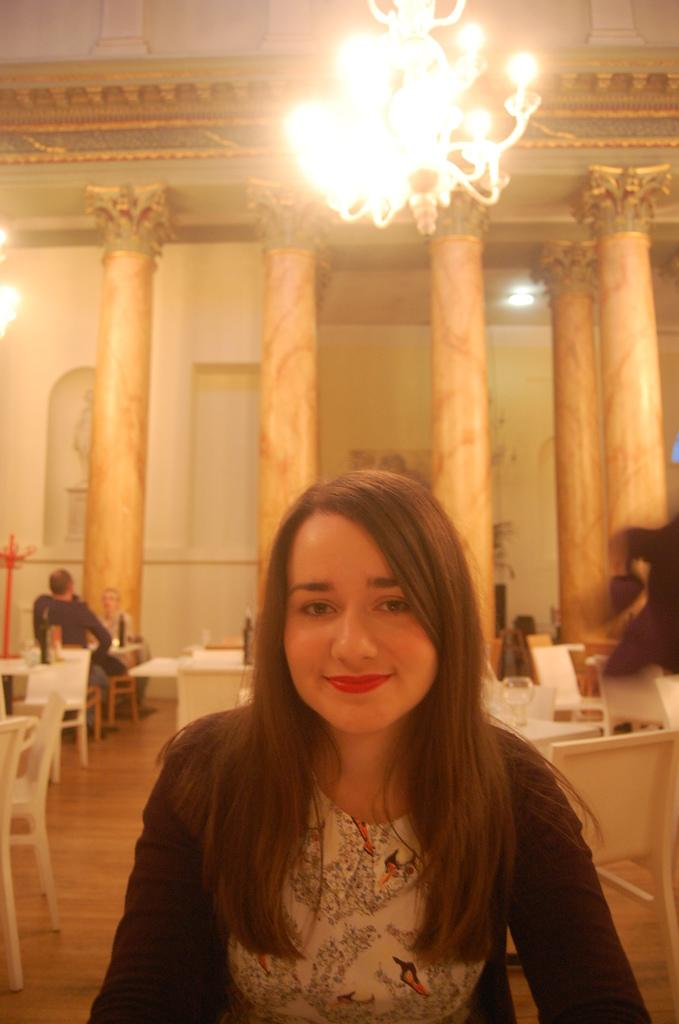Who is present in the image? There is a woman in the image. What is the woman doing in the image? The woman is sitting on a chair and smiling. What can be seen in the background of the image? There is a pillar in the background of the image. What type of lighting fixture is visible in the image? There is a chandelier in the image. What type of pancake is the woman folding in the image? There is no pancake present in the image, and the woman is not folding anything. 